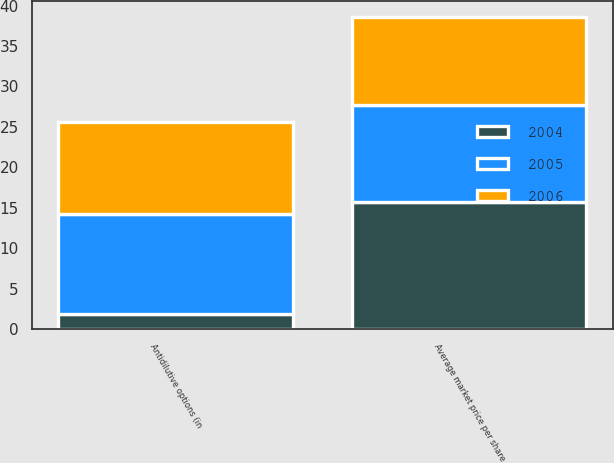Convert chart to OTSL. <chart><loc_0><loc_0><loc_500><loc_500><stacked_bar_chart><ecel><fcel>Antidilutive options (in<fcel>Average market price per share<nl><fcel>2004<fcel>1.9<fcel>15.68<nl><fcel>2006<fcel>11.4<fcel>10.88<nl><fcel>2005<fcel>12.3<fcel>12.03<nl></chart> 